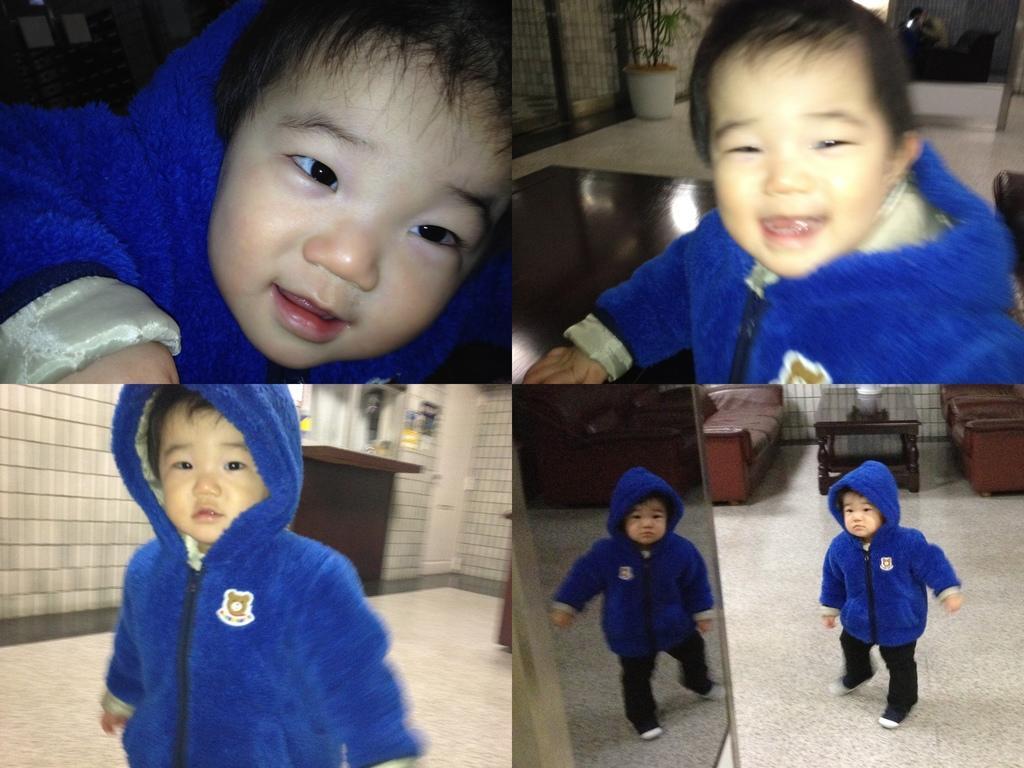How would you summarize this image in a sentence or two? In this image there is a collage of photos of a boy wearing sweater. Right top there is a pot on the floor. Pot is having a plant. Right bottom there is a table. Beside there are few chairs and sofa. The kid is walking on the floor. 